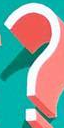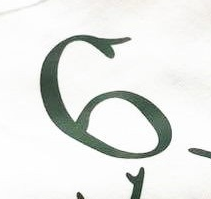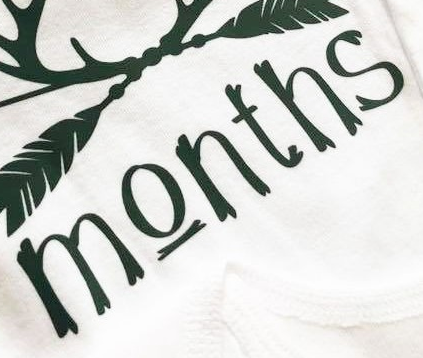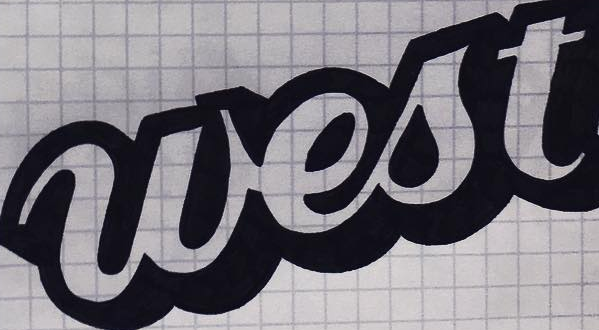Transcribe the words shown in these images in order, separated by a semicolon. ?; 6; Months; west 